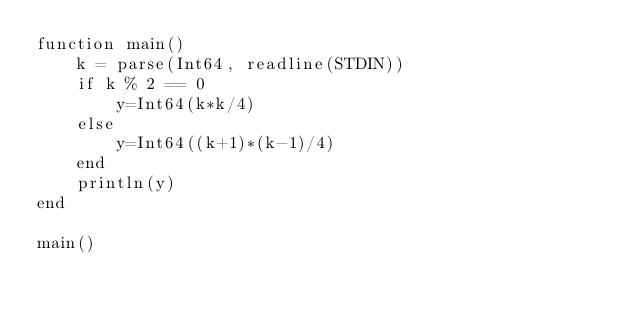<code> <loc_0><loc_0><loc_500><loc_500><_Julia_>function main()
	k = parse(Int64, readline(STDIN))
	if k % 2 == 0
		y=Int64(k*k/4)
	else
		y=Int64((k+1)*(k-1)/4)
	end
	println(y)
end

main()</code> 